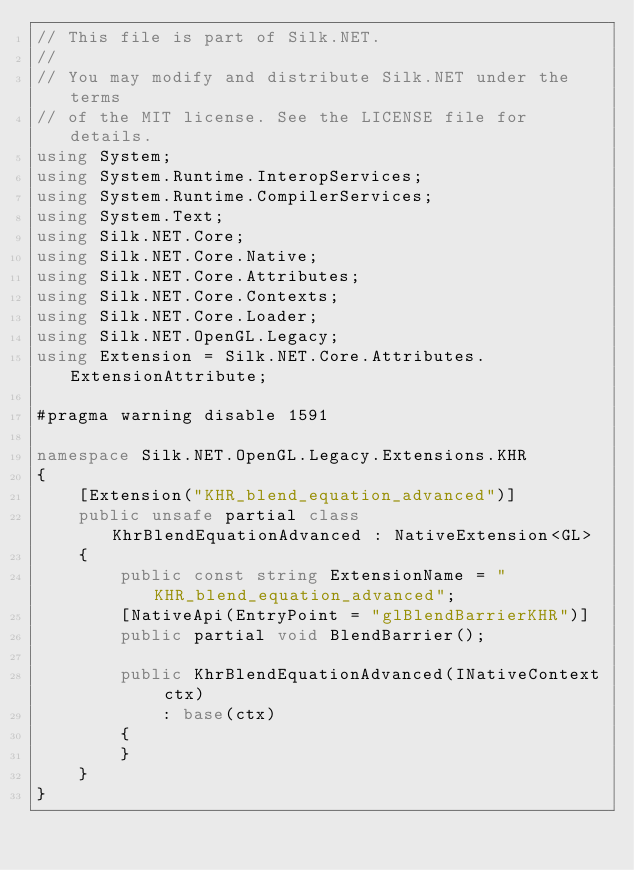Convert code to text. <code><loc_0><loc_0><loc_500><loc_500><_C#_>// This file is part of Silk.NET.
// 
// You may modify and distribute Silk.NET under the terms
// of the MIT license. See the LICENSE file for details.
using System;
using System.Runtime.InteropServices;
using System.Runtime.CompilerServices;
using System.Text;
using Silk.NET.Core;
using Silk.NET.Core.Native;
using Silk.NET.Core.Attributes;
using Silk.NET.Core.Contexts;
using Silk.NET.Core.Loader;
using Silk.NET.OpenGL.Legacy;
using Extension = Silk.NET.Core.Attributes.ExtensionAttribute;

#pragma warning disable 1591

namespace Silk.NET.OpenGL.Legacy.Extensions.KHR
{
    [Extension("KHR_blend_equation_advanced")]
    public unsafe partial class KhrBlendEquationAdvanced : NativeExtension<GL>
    {
        public const string ExtensionName = "KHR_blend_equation_advanced";
        [NativeApi(EntryPoint = "glBlendBarrierKHR")]
        public partial void BlendBarrier();

        public KhrBlendEquationAdvanced(INativeContext ctx)
            : base(ctx)
        {
        }
    }
}

</code> 